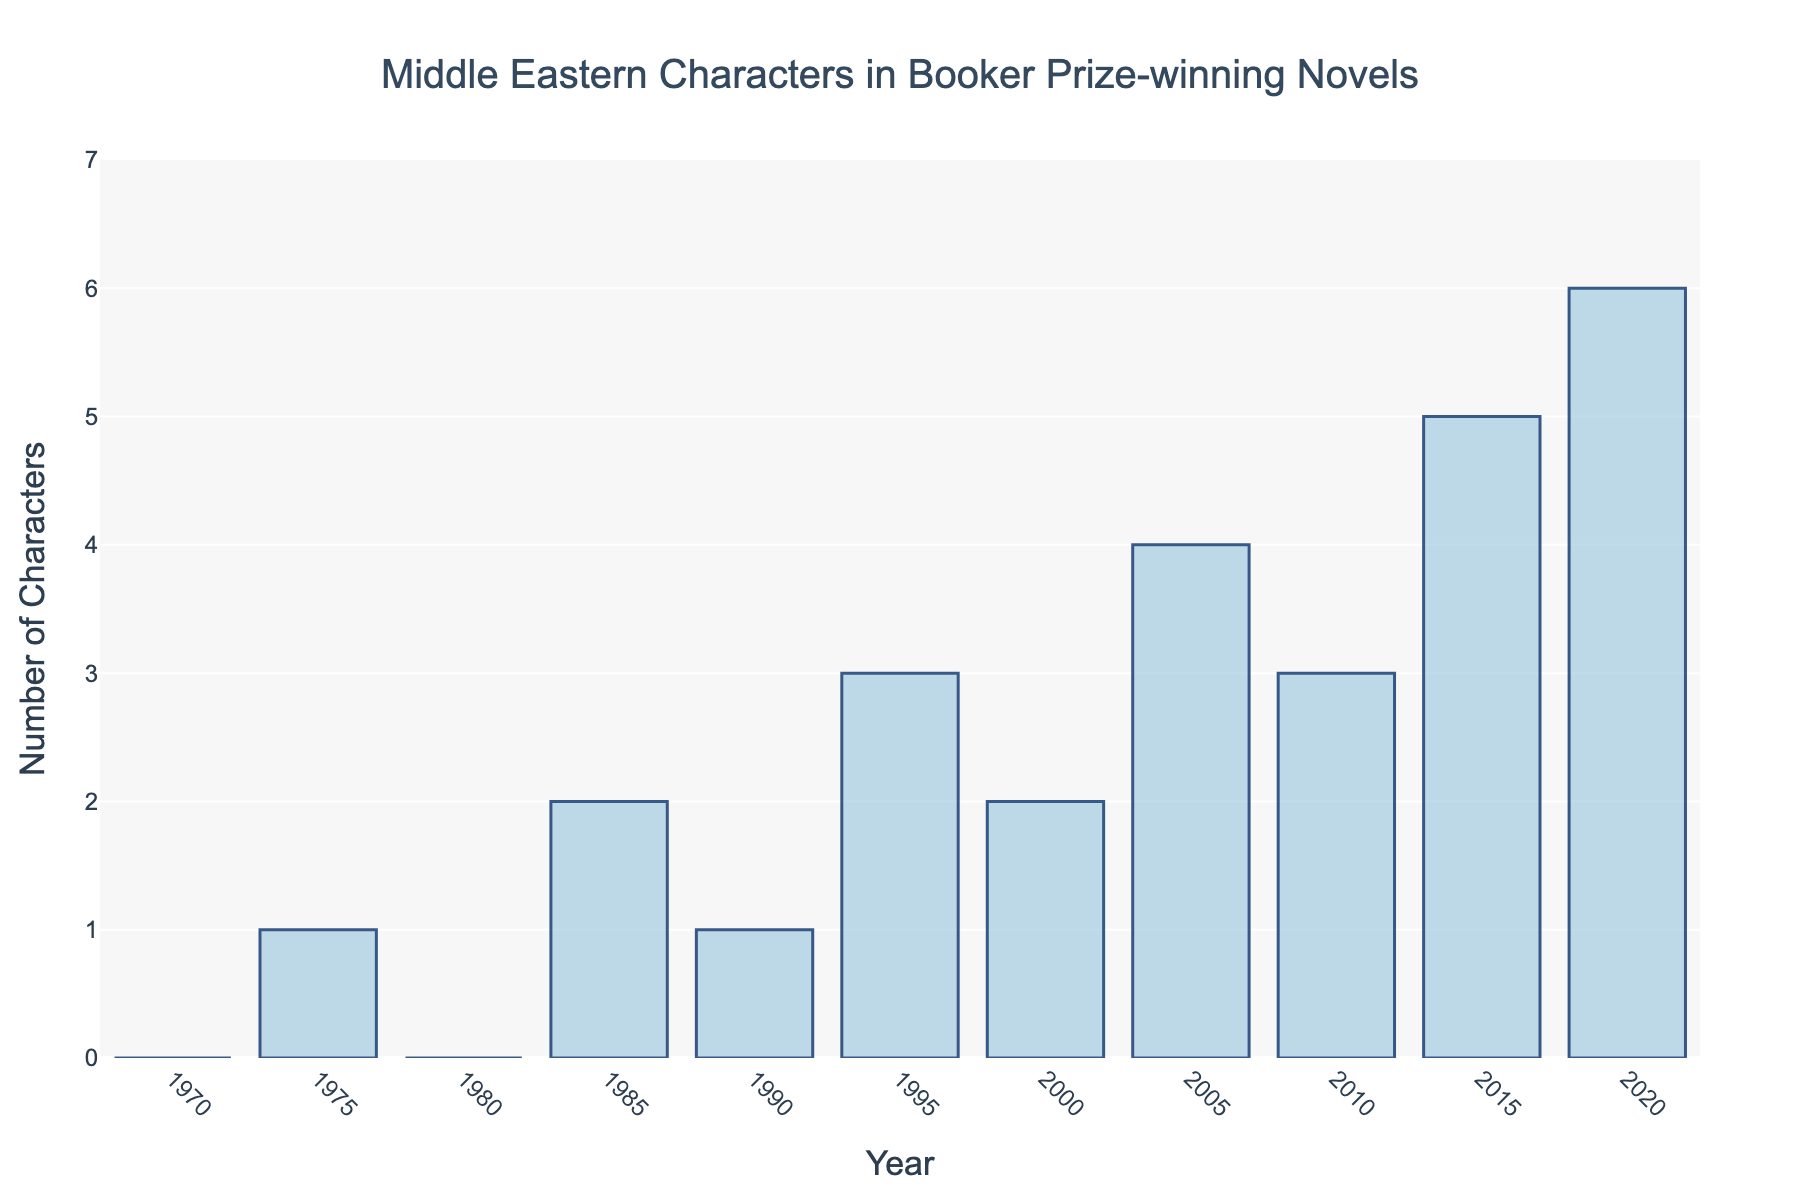Which year has the highest number of Middle Eastern characters? The bar for the year 2020 reaches the highest point on the y-axis, corresponding to 6 characters.
Answer: 2020 How many characters are represented in the years 1985 and 2000 combined? The chart shows that 1985 has 2 characters and 2000 also has 2 characters. Summing these up, 2 + 2 = 4.
Answer: 4 Is the number of characters in 1995 greater than in 1985? The chart shows that 1995 has 3 characters while 1985 has 2 characters. Thus, 3 is greater than 2.
Answer: Yes When did the number of characters first exceed 3? The chart shows that only in the year 2005 does the number of characters exceed 3, with 4 characters represented.
Answer: 2005 What is the average number of characters represented in the years 2000, 2005, 2010, and 2015? Summing the number of characters from 2000 (2), 2005 (4), 2010 (3), and 2015 (5) gives 14. Dividing by the 4 years results in an average of 14 / 4 = 3.5.
Answer: 3.5 What is the difference in character count between 2015 and 1975? The chart shows that 2015 has 5 characters and 1975 has 1 character. The difference is 5 - 1 = 4.
Answer: 4 What is the trend in the number of Middle Eastern characters from 1985 to 2020? Observing the bars from 1985 (2 characters) to 2020 (6 characters), there is a general increasing trend in the number of characters over this period.
Answer: Increasing How many years show exactly 2 Middle Eastern characters? The chart shows that the years 1985 and 2000 each have 2 characters.
Answer: 2 years How does the number of Middle Eastern characters in 1990 compare to 1980? The chart indicates that 1990 has 1 character and 1980 has 0 characters. 1 is greater than 0.
Answer: 1990 is greater What's the sum of characters represented in the first half-decade and the last half-decade shown in the chart? The first half-decade (1970-1974) shows 0 characters over 1 year, and the last half-decade (2016-2020) shows 5 characters in 2015 and 6 in 2020, summing up to 5 + 6 = 11.
Answer: 11 